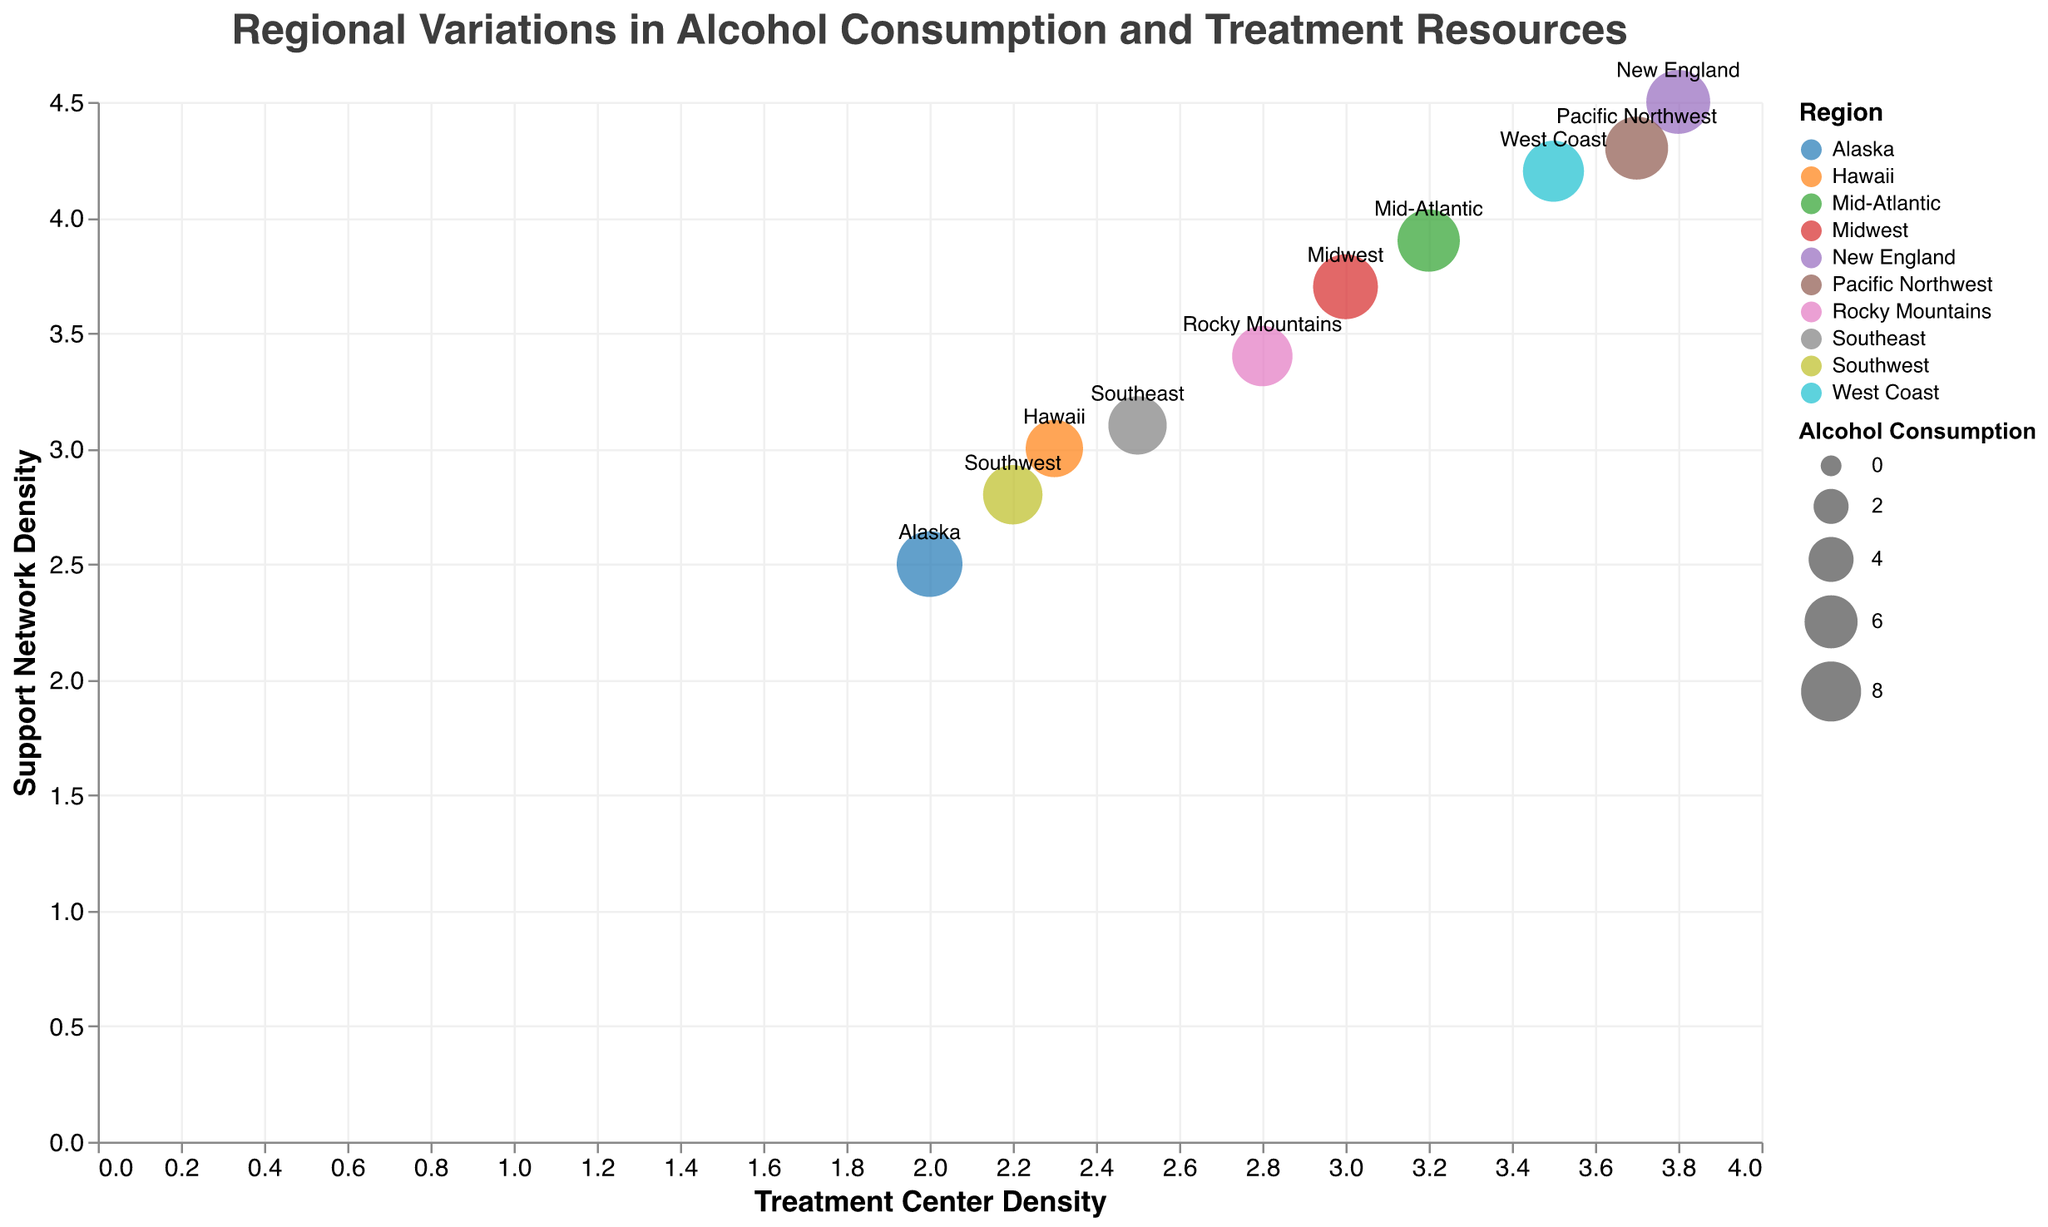What is the title of the figure? The title of the figure is displayed at the top and can be read directly from the visual.
Answer: Regional Variations in Alcohol Consumption and Treatment Resources How many regions are represented in the figure? Count the unique labels or points in the figure, each representing a different region.
Answer: 10 Which region has the highest alcohol consumption? Look for the largest circle in the plot, as the size of the circle represents alcohol consumption.
Answer: Alaska Which region has the lowest density of addiction treatment centers? Check the horizontal axis for the lowest point and refer to its corresponding region label.
Answer: Alaska Which two regions have similar support network density but different alcohol consumption rates? Identify two points with similar y-axis values but noticeable difference in circle sizes, and check their region labels.
Answer: New England and Pacific Northwest What is the average alcohol consumption for all regions? Sum all the alcohol consumption values (9.2 + 8.7 + 7.5 + 9.5 + 7.8 + 8.3 + 8.9 + 8.1 + 9.8 + 7.2) and divide by the number of regions (10).
Answer: 8.5 Is there a region where both the treatment center density and support network density are below 3? Look for a point that is below 3 on both the x-axis and y-axis.
Answer: Alaska Which region has the highest support network density? Look for the highest point on the y-axis and check its corresponding region label.
Answer: New England Compare the alcohol consumption between the Midwest and Southeast regions. Note the sizes of the circles labeled Midwest and Southeast, represented by their alcohol consumption values.
Answer: Midwest (9.5) is higher than Southeast (7.5) Does the Mid-Atlantic region have a higher or lower treatment center density compared to the West Coast? Compare the positions on the x-axis for the points labeled Mid-Atlantic and West Coast.
Answer: Lower 